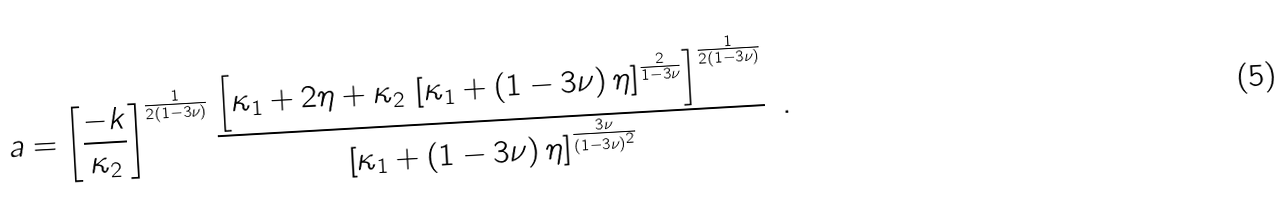<formula> <loc_0><loc_0><loc_500><loc_500>a = \left [ \frac { - k } { \kappa _ { 2 } } \right ] ^ { \frac { 1 } { 2 ( 1 - 3 \nu ) } } \frac { \left [ \kappa _ { 1 } + 2 \eta + \kappa _ { 2 } \, \left [ \kappa _ { 1 } + ( 1 - 3 \nu ) \, \eta \right ] ^ { \frac { 2 } { 1 - 3 \nu } } \right ] ^ { \frac { 1 } { 2 ( 1 - 3 \nu ) } } } { \left [ \kappa _ { 1 } + ( 1 - 3 \nu ) \, \eta \right ] ^ { \frac { 3 \nu } { ( 1 - 3 \nu ) ^ { 2 } } } } \, \ .</formula> 